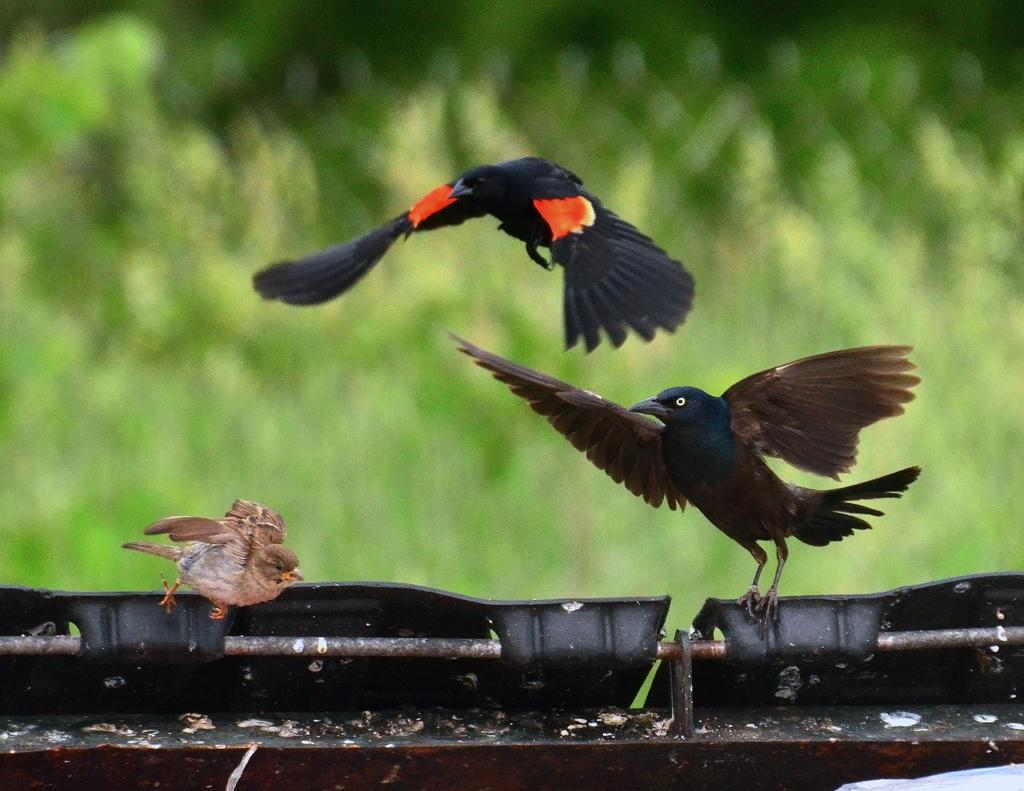What is happening in the image involving animals? There are birds flying in the image. Can you describe the colors of the birds? The birds are in black, brown, and orange colors. What color is the object in the image? There is a black color object in the image. What is the color of the background in the image? The background of the image is green. Where is the wheel located in the image? There is no wheel present in the image. What type of mailbox can be seen in the image? There is no mailbox present in the image. 